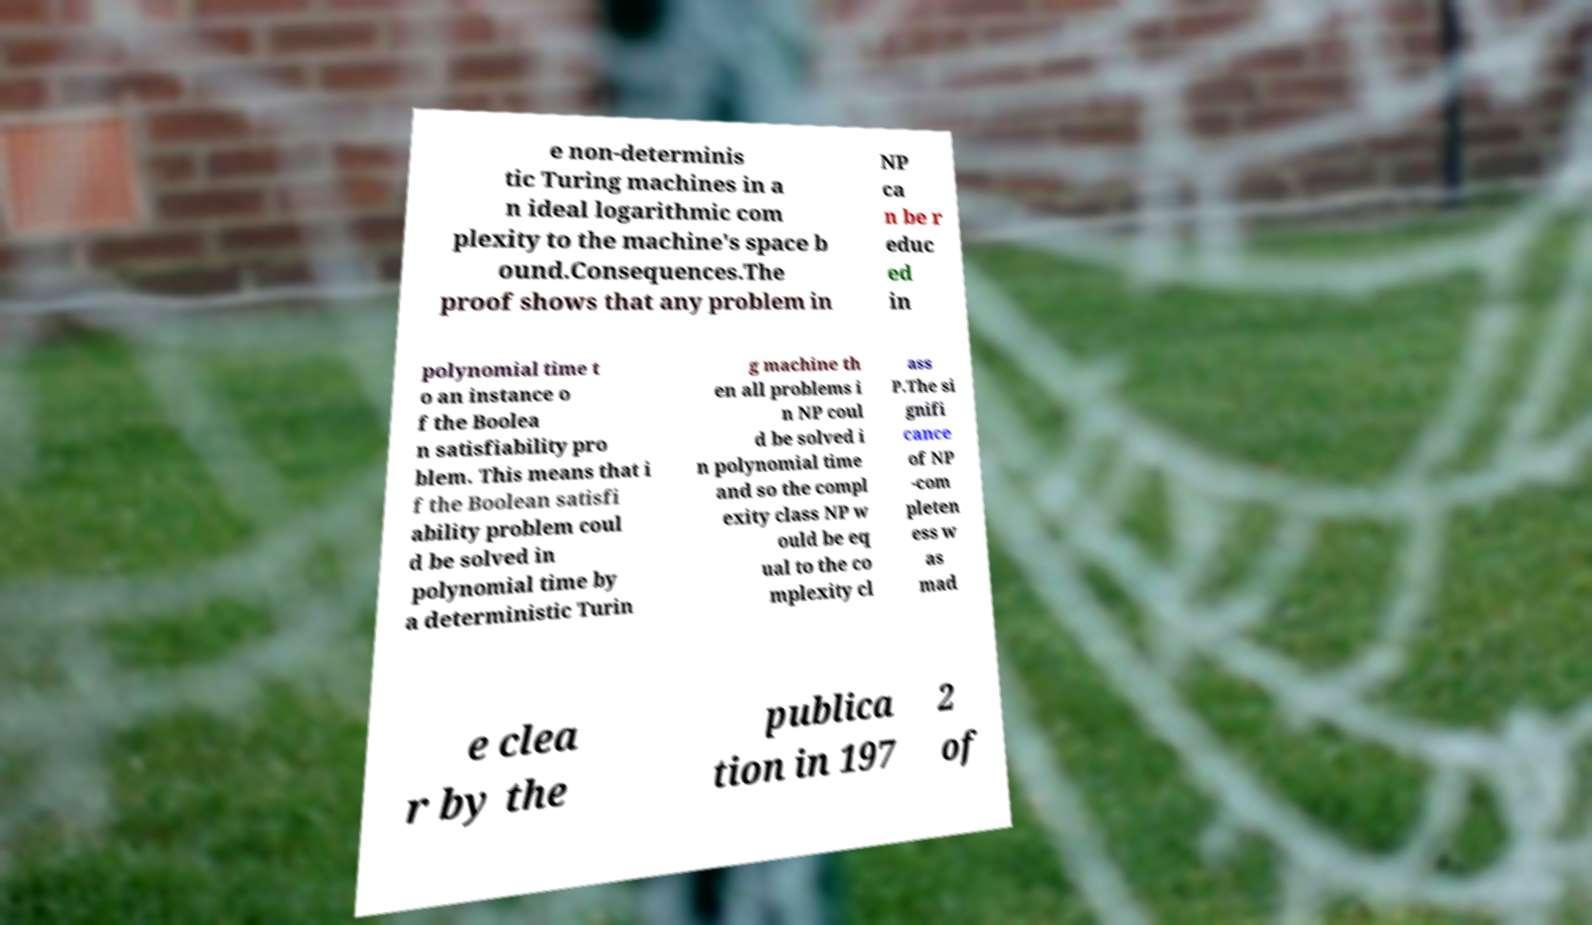There's text embedded in this image that I need extracted. Can you transcribe it verbatim? e non-determinis tic Turing machines in a n ideal logarithmic com plexity to the machine's space b ound.Consequences.The proof shows that any problem in NP ca n be r educ ed in polynomial time t o an instance o f the Boolea n satisfiability pro blem. This means that i f the Boolean satisfi ability problem coul d be solved in polynomial time by a deterministic Turin g machine th en all problems i n NP coul d be solved i n polynomial time and so the compl exity class NP w ould be eq ual to the co mplexity cl ass P.The si gnifi cance of NP -com pleten ess w as mad e clea r by the publica tion in 197 2 of 